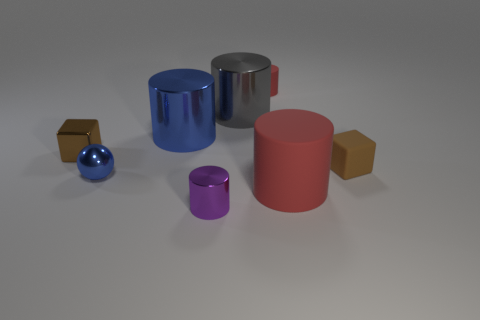What is the shape of the metallic thing that is the same size as the blue metallic cylinder?
Give a very brief answer. Cylinder. Does the tiny purple shiny object have the same shape as the large red object?
Provide a succinct answer. Yes. How many rubber objects have the same shape as the brown metallic object?
Offer a terse response. 1. There is a brown matte cube; how many large red matte cylinders are right of it?
Offer a terse response. 0. Do the tiny block that is left of the gray object and the tiny matte cube have the same color?
Your response must be concise. Yes. What number of gray cylinders are the same size as the purple metal object?
Give a very brief answer. 0. There is a tiny red thing that is made of the same material as the large red cylinder; what shape is it?
Your answer should be compact. Cylinder. Are there any small shiny objects that have the same color as the matte block?
Keep it short and to the point. Yes. What is the material of the tiny red cylinder?
Provide a succinct answer. Rubber. What number of objects are brown matte cubes or small purple shiny things?
Your response must be concise. 2. 